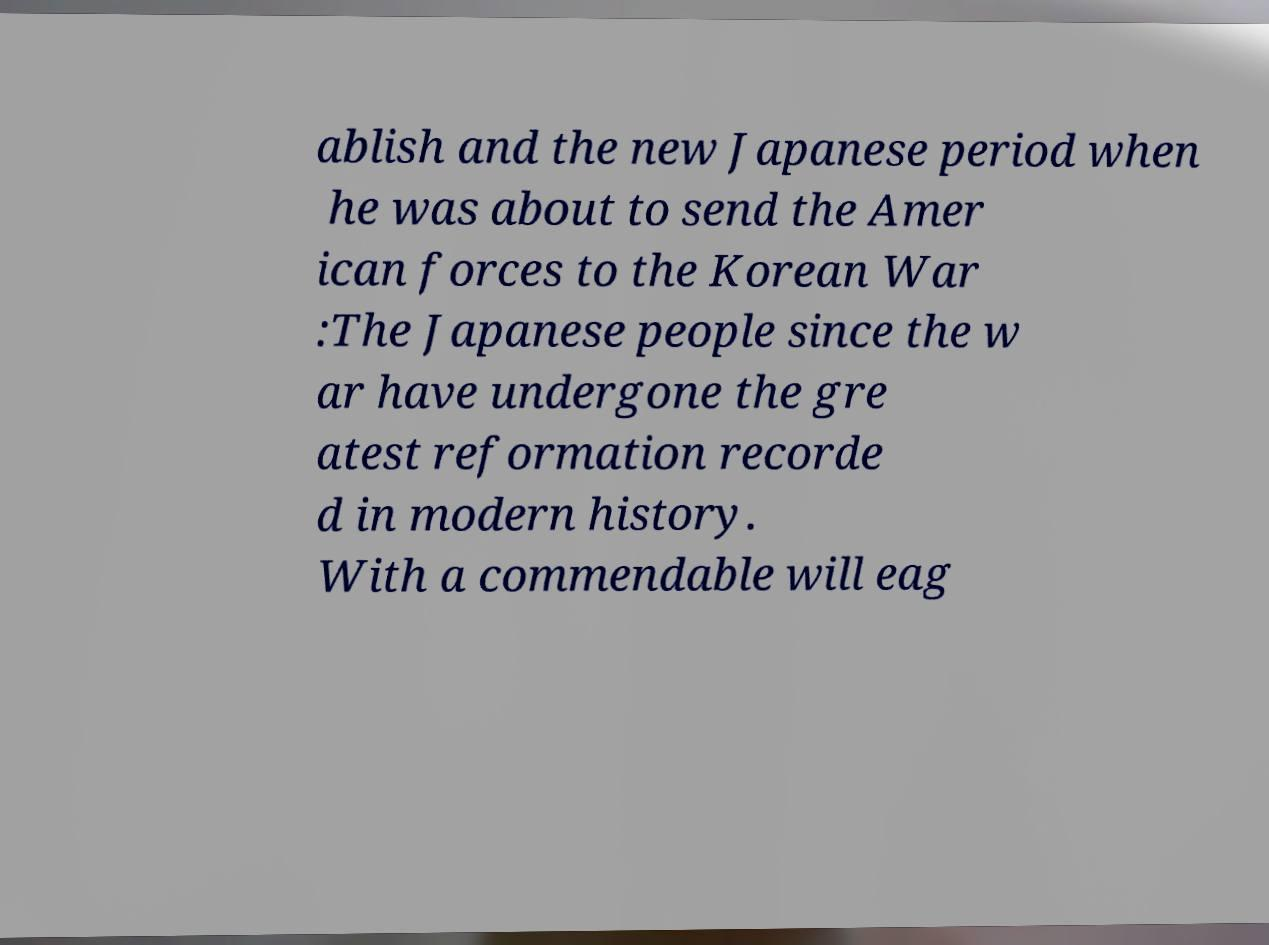Can you read and provide the text displayed in the image?This photo seems to have some interesting text. Can you extract and type it out for me? ablish and the new Japanese period when he was about to send the Amer ican forces to the Korean War :The Japanese people since the w ar have undergone the gre atest reformation recorde d in modern history. With a commendable will eag 